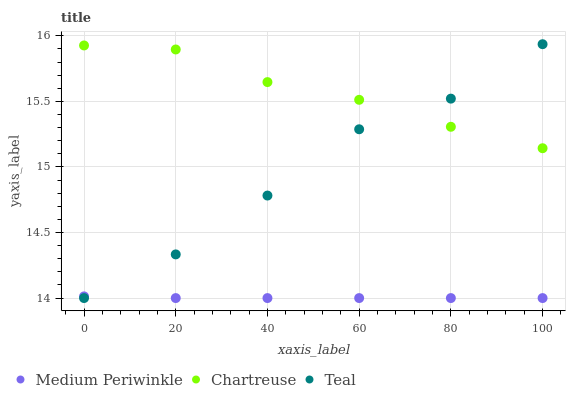Does Medium Periwinkle have the minimum area under the curve?
Answer yes or no. Yes. Does Chartreuse have the maximum area under the curve?
Answer yes or no. Yes. Does Teal have the minimum area under the curve?
Answer yes or no. No. Does Teal have the maximum area under the curve?
Answer yes or no. No. Is Medium Periwinkle the smoothest?
Answer yes or no. Yes. Is Teal the roughest?
Answer yes or no. Yes. Is Teal the smoothest?
Answer yes or no. No. Is Medium Periwinkle the roughest?
Answer yes or no. No. Does Medium Periwinkle have the lowest value?
Answer yes or no. Yes. Does Teal have the highest value?
Answer yes or no. Yes. Does Medium Periwinkle have the highest value?
Answer yes or no. No. Is Medium Periwinkle less than Chartreuse?
Answer yes or no. Yes. Is Chartreuse greater than Medium Periwinkle?
Answer yes or no. Yes. Does Teal intersect Medium Periwinkle?
Answer yes or no. Yes. Is Teal less than Medium Periwinkle?
Answer yes or no. No. Is Teal greater than Medium Periwinkle?
Answer yes or no. No. Does Medium Periwinkle intersect Chartreuse?
Answer yes or no. No. 